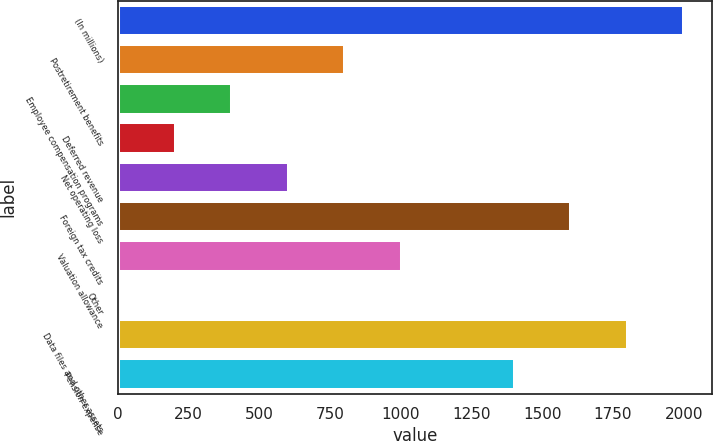Convert chart. <chart><loc_0><loc_0><loc_500><loc_500><bar_chart><fcel>(In millions)<fcel>Postretirement benefits<fcel>Employee compensation programs<fcel>Deferred revenue<fcel>Net operating loss<fcel>Foreign tax credits<fcel>Valuation allowance<fcel>Other<fcel>Data files and other assets<fcel>Pension expense<nl><fcel>2001<fcel>803.16<fcel>403.88<fcel>204.24<fcel>603.52<fcel>1601.72<fcel>1002.8<fcel>4.6<fcel>1801.36<fcel>1402.08<nl></chart> 